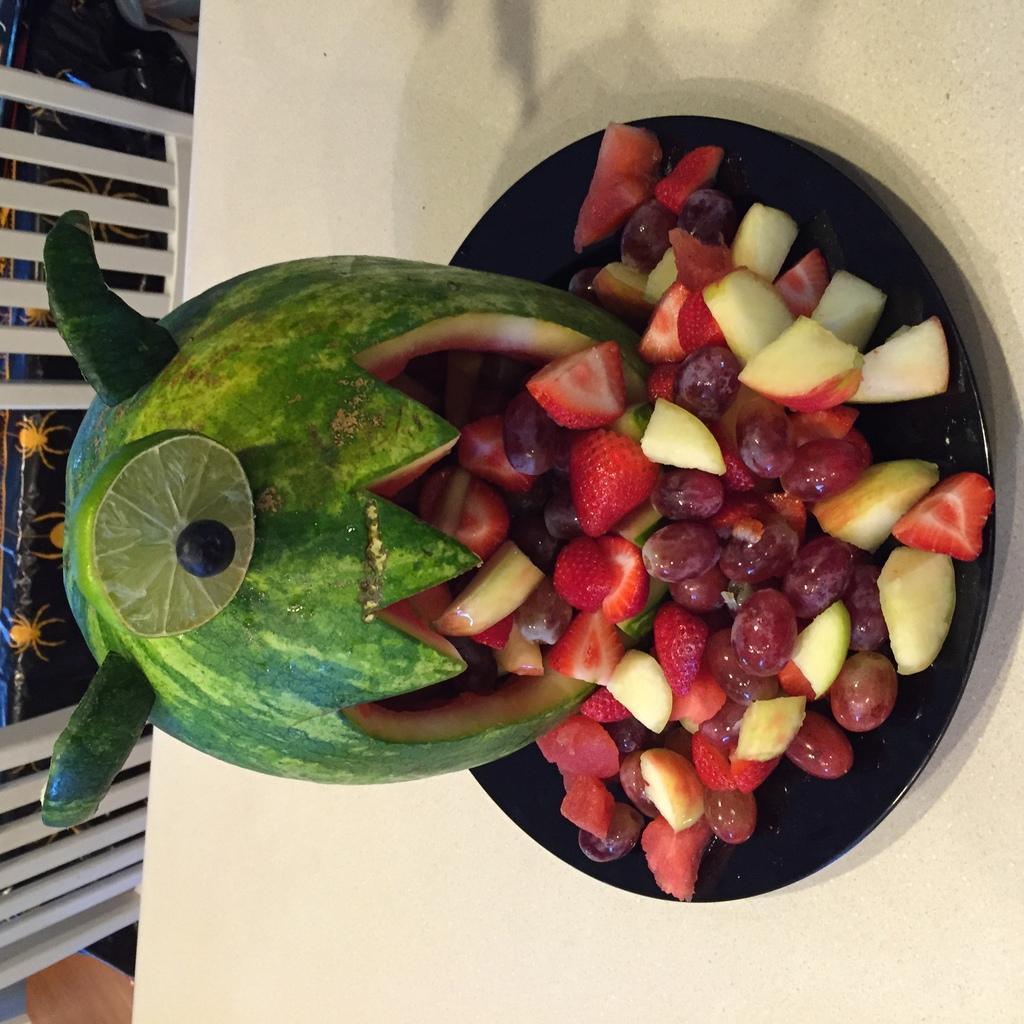Can you describe this image briefly? In this picture there are fruits in the center of the image, which contains, strawberries, apples, and other fruits. 